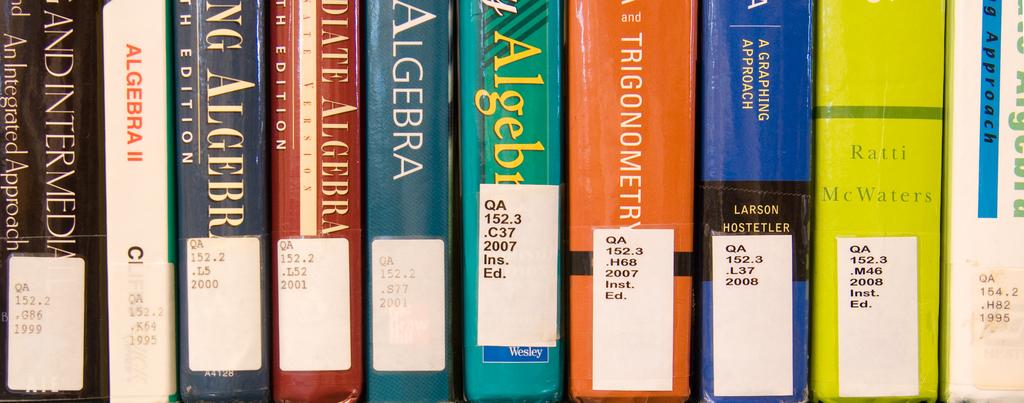What word is wrote on the second book to the left?
Your answer should be very brief. Algebra. 